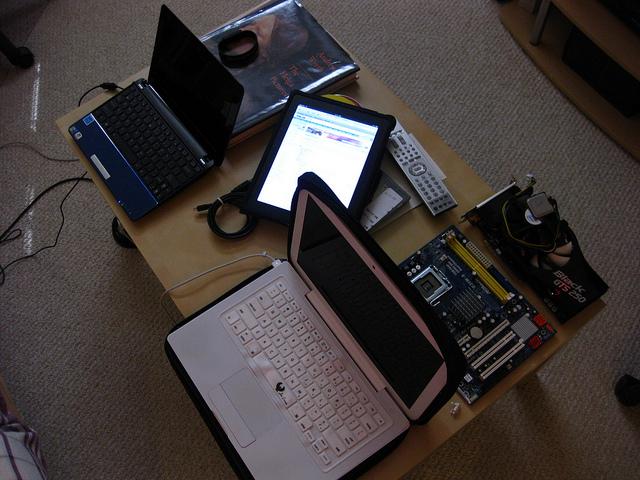Which laptop is bigger?
Give a very brief answer. Right. Is the laptop on?
Give a very brief answer. No. Why are the laptops on the table?
Write a very short answer. Watch. Who is the maker of the monitor on the left?
Short answer required. Apple. What color are the computers?
Quick response, please. White. What is the remote for?
Quick response, please. Tv. Is this a pet?
Quick response, please. No. Where is the laptop?
Quick response, please. On table. Whose picture is on the Kindle?
Quick response, please. None. Would you find the object that's in this photo somewhere on a ship?
Keep it brief. No. How many remotes are there?
Concise answer only. 1. Which object requires batteries to be functional?
Give a very brief answer. Remote. What is behind the screen?
Short answer required. Circuit board. What device is laying on the table?
Short answer required. Laptop. How many computers do you see?
Keep it brief. 2. Does the floor appear to be clean?
Concise answer only. Yes. 